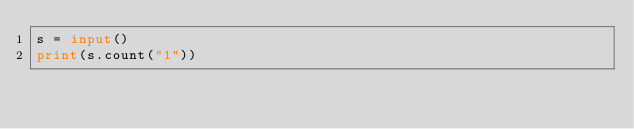<code> <loc_0><loc_0><loc_500><loc_500><_Python_>s = input()
print(s.count("1"))</code> 